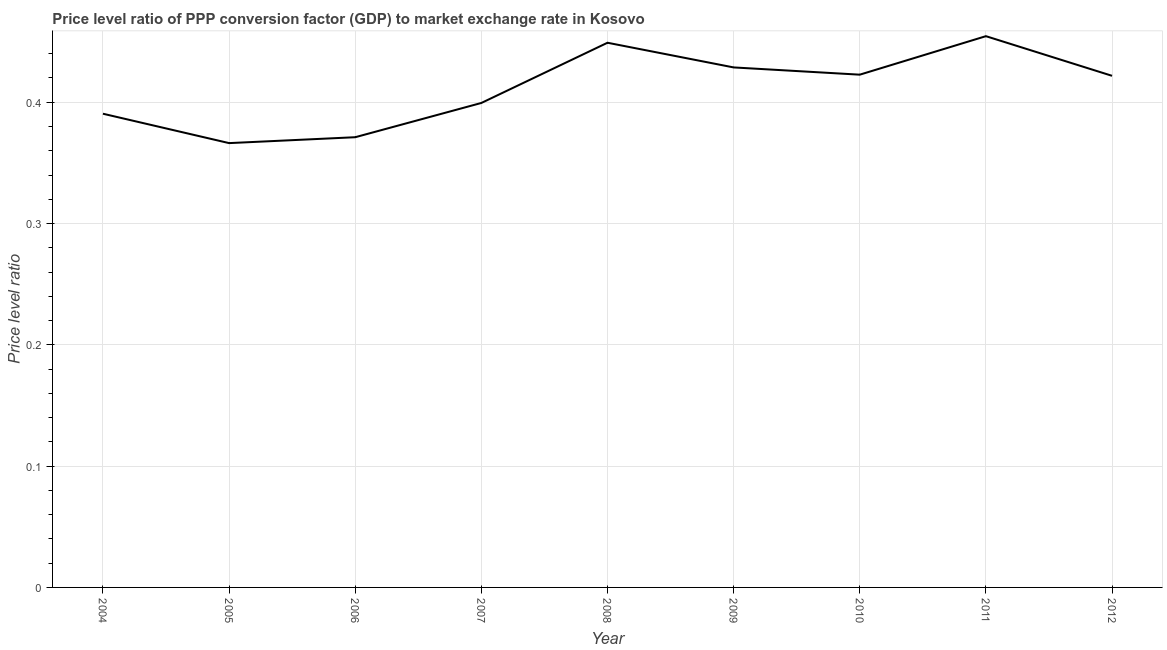What is the price level ratio in 2011?
Provide a short and direct response. 0.45. Across all years, what is the maximum price level ratio?
Provide a succinct answer. 0.45. Across all years, what is the minimum price level ratio?
Provide a succinct answer. 0.37. In which year was the price level ratio maximum?
Ensure brevity in your answer.  2011. In which year was the price level ratio minimum?
Your answer should be compact. 2005. What is the sum of the price level ratio?
Your answer should be compact. 3.7. What is the difference between the price level ratio in 2005 and 2010?
Your response must be concise. -0.06. What is the average price level ratio per year?
Ensure brevity in your answer.  0.41. What is the median price level ratio?
Your response must be concise. 0.42. In how many years, is the price level ratio greater than 0.28 ?
Your answer should be compact. 9. What is the ratio of the price level ratio in 2010 to that in 2012?
Provide a succinct answer. 1. Is the price level ratio in 2005 less than that in 2009?
Make the answer very short. Yes. Is the difference between the price level ratio in 2007 and 2008 greater than the difference between any two years?
Your response must be concise. No. What is the difference between the highest and the second highest price level ratio?
Provide a succinct answer. 0.01. What is the difference between the highest and the lowest price level ratio?
Keep it short and to the point. 0.09. In how many years, is the price level ratio greater than the average price level ratio taken over all years?
Make the answer very short. 5. Does the price level ratio monotonically increase over the years?
Provide a short and direct response. No. What is the difference between two consecutive major ticks on the Y-axis?
Provide a succinct answer. 0.1. What is the title of the graph?
Keep it short and to the point. Price level ratio of PPP conversion factor (GDP) to market exchange rate in Kosovo. What is the label or title of the Y-axis?
Keep it short and to the point. Price level ratio. What is the Price level ratio of 2004?
Provide a succinct answer. 0.39. What is the Price level ratio of 2005?
Provide a short and direct response. 0.37. What is the Price level ratio in 2006?
Your answer should be very brief. 0.37. What is the Price level ratio in 2007?
Your answer should be very brief. 0.4. What is the Price level ratio of 2008?
Ensure brevity in your answer.  0.45. What is the Price level ratio of 2009?
Keep it short and to the point. 0.43. What is the Price level ratio of 2010?
Offer a very short reply. 0.42. What is the Price level ratio of 2011?
Your response must be concise. 0.45. What is the Price level ratio of 2012?
Keep it short and to the point. 0.42. What is the difference between the Price level ratio in 2004 and 2005?
Your response must be concise. 0.02. What is the difference between the Price level ratio in 2004 and 2006?
Offer a very short reply. 0.02. What is the difference between the Price level ratio in 2004 and 2007?
Provide a succinct answer. -0.01. What is the difference between the Price level ratio in 2004 and 2008?
Your answer should be compact. -0.06. What is the difference between the Price level ratio in 2004 and 2009?
Your answer should be compact. -0.04. What is the difference between the Price level ratio in 2004 and 2010?
Your answer should be very brief. -0.03. What is the difference between the Price level ratio in 2004 and 2011?
Keep it short and to the point. -0.06. What is the difference between the Price level ratio in 2004 and 2012?
Keep it short and to the point. -0.03. What is the difference between the Price level ratio in 2005 and 2006?
Offer a very short reply. -0. What is the difference between the Price level ratio in 2005 and 2007?
Your answer should be very brief. -0.03. What is the difference between the Price level ratio in 2005 and 2008?
Make the answer very short. -0.08. What is the difference between the Price level ratio in 2005 and 2009?
Offer a terse response. -0.06. What is the difference between the Price level ratio in 2005 and 2010?
Your answer should be compact. -0.06. What is the difference between the Price level ratio in 2005 and 2011?
Your response must be concise. -0.09. What is the difference between the Price level ratio in 2005 and 2012?
Make the answer very short. -0.06. What is the difference between the Price level ratio in 2006 and 2007?
Offer a terse response. -0.03. What is the difference between the Price level ratio in 2006 and 2008?
Ensure brevity in your answer.  -0.08. What is the difference between the Price level ratio in 2006 and 2009?
Provide a succinct answer. -0.06. What is the difference between the Price level ratio in 2006 and 2010?
Ensure brevity in your answer.  -0.05. What is the difference between the Price level ratio in 2006 and 2011?
Ensure brevity in your answer.  -0.08. What is the difference between the Price level ratio in 2006 and 2012?
Offer a very short reply. -0.05. What is the difference between the Price level ratio in 2007 and 2008?
Give a very brief answer. -0.05. What is the difference between the Price level ratio in 2007 and 2009?
Your response must be concise. -0.03. What is the difference between the Price level ratio in 2007 and 2010?
Provide a short and direct response. -0.02. What is the difference between the Price level ratio in 2007 and 2011?
Provide a succinct answer. -0.06. What is the difference between the Price level ratio in 2007 and 2012?
Offer a very short reply. -0.02. What is the difference between the Price level ratio in 2008 and 2009?
Provide a succinct answer. 0.02. What is the difference between the Price level ratio in 2008 and 2010?
Provide a succinct answer. 0.03. What is the difference between the Price level ratio in 2008 and 2011?
Your answer should be very brief. -0.01. What is the difference between the Price level ratio in 2008 and 2012?
Ensure brevity in your answer.  0.03. What is the difference between the Price level ratio in 2009 and 2010?
Your answer should be very brief. 0.01. What is the difference between the Price level ratio in 2009 and 2011?
Your answer should be very brief. -0.03. What is the difference between the Price level ratio in 2009 and 2012?
Provide a short and direct response. 0.01. What is the difference between the Price level ratio in 2010 and 2011?
Your response must be concise. -0.03. What is the difference between the Price level ratio in 2010 and 2012?
Your response must be concise. 0. What is the difference between the Price level ratio in 2011 and 2012?
Provide a succinct answer. 0.03. What is the ratio of the Price level ratio in 2004 to that in 2005?
Provide a short and direct response. 1.07. What is the ratio of the Price level ratio in 2004 to that in 2006?
Make the answer very short. 1.05. What is the ratio of the Price level ratio in 2004 to that in 2007?
Offer a very short reply. 0.98. What is the ratio of the Price level ratio in 2004 to that in 2008?
Your answer should be compact. 0.87. What is the ratio of the Price level ratio in 2004 to that in 2009?
Ensure brevity in your answer.  0.91. What is the ratio of the Price level ratio in 2004 to that in 2010?
Your answer should be compact. 0.92. What is the ratio of the Price level ratio in 2004 to that in 2011?
Offer a terse response. 0.86. What is the ratio of the Price level ratio in 2004 to that in 2012?
Your answer should be very brief. 0.93. What is the ratio of the Price level ratio in 2005 to that in 2006?
Offer a terse response. 0.99. What is the ratio of the Price level ratio in 2005 to that in 2007?
Your answer should be very brief. 0.92. What is the ratio of the Price level ratio in 2005 to that in 2008?
Provide a succinct answer. 0.82. What is the ratio of the Price level ratio in 2005 to that in 2009?
Make the answer very short. 0.85. What is the ratio of the Price level ratio in 2005 to that in 2010?
Offer a terse response. 0.87. What is the ratio of the Price level ratio in 2005 to that in 2011?
Make the answer very short. 0.81. What is the ratio of the Price level ratio in 2005 to that in 2012?
Offer a very short reply. 0.87. What is the ratio of the Price level ratio in 2006 to that in 2007?
Offer a terse response. 0.93. What is the ratio of the Price level ratio in 2006 to that in 2008?
Provide a short and direct response. 0.83. What is the ratio of the Price level ratio in 2006 to that in 2009?
Ensure brevity in your answer.  0.87. What is the ratio of the Price level ratio in 2006 to that in 2010?
Keep it short and to the point. 0.88. What is the ratio of the Price level ratio in 2006 to that in 2011?
Your answer should be very brief. 0.82. What is the ratio of the Price level ratio in 2007 to that in 2008?
Provide a succinct answer. 0.89. What is the ratio of the Price level ratio in 2007 to that in 2009?
Give a very brief answer. 0.93. What is the ratio of the Price level ratio in 2007 to that in 2010?
Keep it short and to the point. 0.94. What is the ratio of the Price level ratio in 2007 to that in 2011?
Offer a terse response. 0.88. What is the ratio of the Price level ratio in 2007 to that in 2012?
Provide a succinct answer. 0.95. What is the ratio of the Price level ratio in 2008 to that in 2009?
Your answer should be very brief. 1.05. What is the ratio of the Price level ratio in 2008 to that in 2010?
Provide a short and direct response. 1.06. What is the ratio of the Price level ratio in 2008 to that in 2011?
Offer a terse response. 0.99. What is the ratio of the Price level ratio in 2008 to that in 2012?
Offer a very short reply. 1.06. What is the ratio of the Price level ratio in 2009 to that in 2010?
Your answer should be very brief. 1.01. What is the ratio of the Price level ratio in 2009 to that in 2011?
Give a very brief answer. 0.94. What is the ratio of the Price level ratio in 2009 to that in 2012?
Provide a succinct answer. 1.02. What is the ratio of the Price level ratio in 2011 to that in 2012?
Your answer should be very brief. 1.08. 